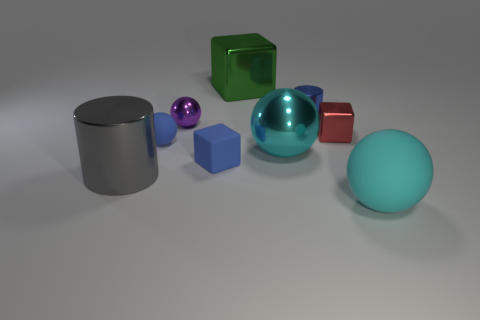What is the color of the small matte thing that is the same shape as the large green shiny object?
Provide a short and direct response. Blue. Are there any other things that have the same shape as the cyan shiny thing?
Your answer should be very brief. Yes. The red metal thing on the right side of the small matte block has what shape?
Provide a short and direct response. Cube. What number of red objects are the same shape as the large green shiny thing?
Provide a short and direct response. 1. Does the large ball behind the large matte object have the same color as the rubber sphere that is in front of the small matte ball?
Give a very brief answer. Yes. How many things are cyan objects or big yellow rubber cubes?
Offer a very short reply. 2. How many tiny red blocks have the same material as the purple sphere?
Make the answer very short. 1. Is the number of big purple metallic cylinders less than the number of cyan objects?
Ensure brevity in your answer.  Yes. Is the cyan thing that is in front of the blue matte cube made of the same material as the green block?
Offer a terse response. No. What number of blocks are either small green objects or red objects?
Keep it short and to the point. 1. 